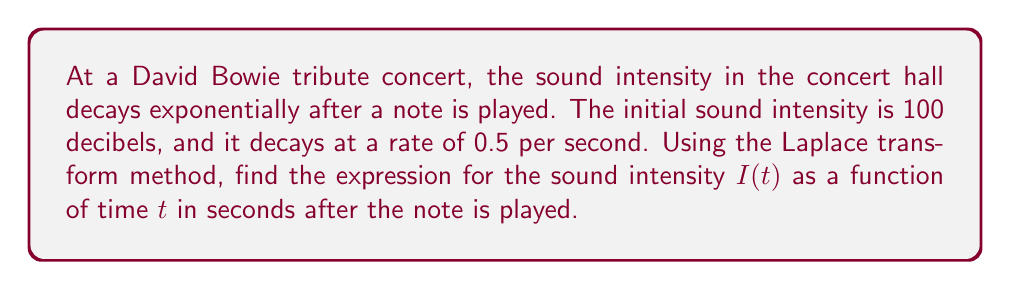Help me with this question. Let's approach this step-by-step using the Laplace transform method:

1) The general form of exponential decay is:
   $$I(t) = I_0 e^{-kt}$$
   where $I_0$ is the initial intensity and $k$ is the decay rate.

2) In this case, $I_0 = 100$ and $k = 0.5$. So our equation is:
   $$I(t) = 100e^{-0.5t}$$

3) To solve this using Laplace transforms, let's denote the Laplace transform of $I(t)$ as $\mathcal{L}\{I(t)\} = F(s)$.

4) We know from Laplace transform properties that:
   $$\mathcal{L}\{ae^{bt}\} = \frac{a}{s-b}$$

5) In our case, $a = 100$ and $b = -0.5$. So:
   $$F(s) = \frac{100}{s+0.5}$$

6) To get back to the time domain, we need to find the inverse Laplace transform of $F(s)$:
   $$I(t) = \mathcal{L}^{-1}\{F(s)\} = \mathcal{L}^{-1}\left\{\frac{100}{s+0.5}\right\}$$

7) Using the inverse Laplace transform property:
   $$\mathcal{L}^{-1}\left\{\frac{a}{s+b}\right\} = ae^{-bt}$$

8) Therefore:
   $$I(t) = 100e^{-0.5t}$$

This matches our original equation, confirming our solution.
Answer: $$I(t) = 100e^{-0.5t}$$ decibels 